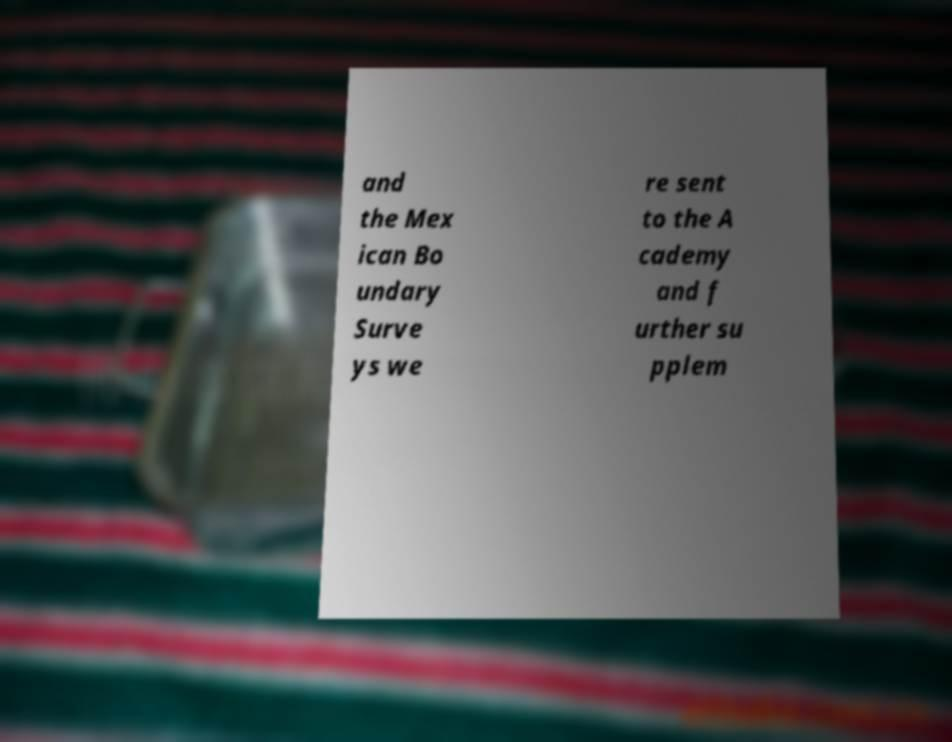For documentation purposes, I need the text within this image transcribed. Could you provide that? and the Mex ican Bo undary Surve ys we re sent to the A cademy and f urther su pplem 